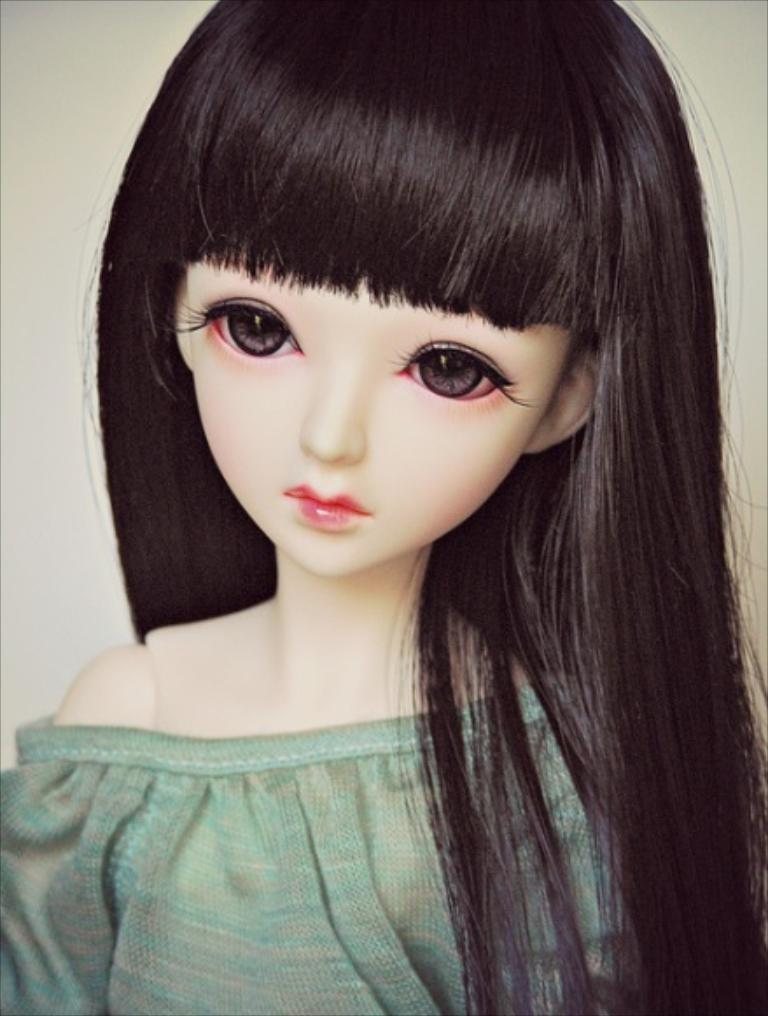What is the main subject in the image? There is a doll in the image. What color is the background of the image? The background of the image is white. Is the doll wearing a crown in the image? There is no crown visible on the doll in the image. What type of amusement park can be seen in the background of the image? There is no amusement park present in the image; the background is white. 